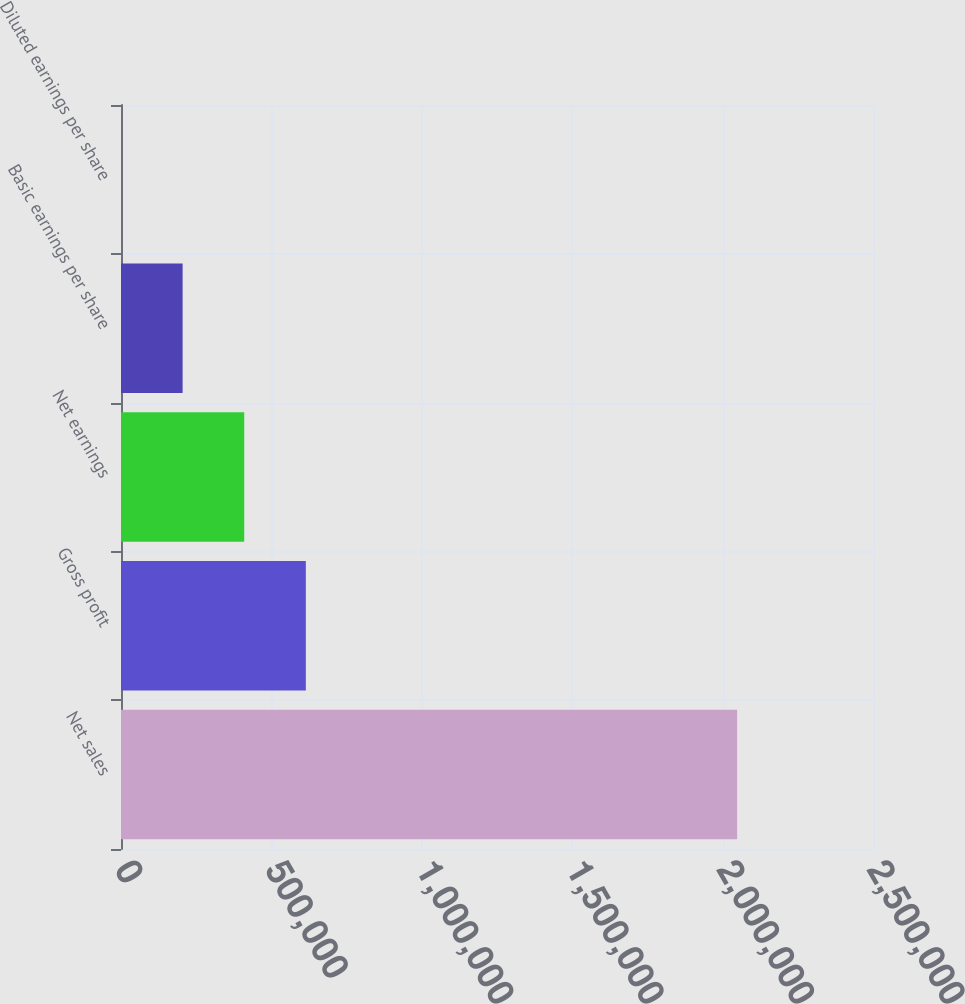Convert chart. <chart><loc_0><loc_0><loc_500><loc_500><bar_chart><fcel>Net sales<fcel>Gross profit<fcel>Net earnings<fcel>Basic earnings per share<fcel>Diluted earnings per share<nl><fcel>2.04825e+06<fcel>614476<fcel>409651<fcel>204827<fcel>2.08<nl></chart> 